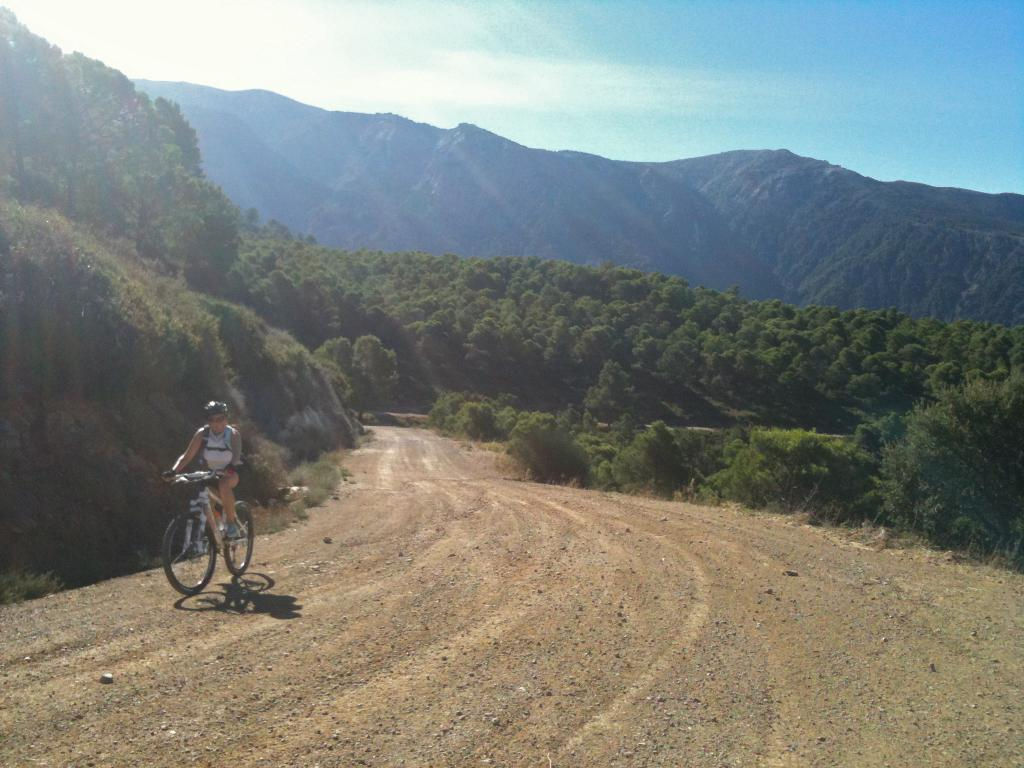What is the person on the left side of the image doing? There is a person riding a bicycle on the left side of the image. What can be seen in the background of the image? There are trees and hills in the background of the image. What is visible in the sky in the image? The sky is visible in the background of the image. What type of machine is the grandfather using to ride the bicycle in the image? There is no mention of a grandfather or a machine in the image; it simply shows a person riding a bicycle. 